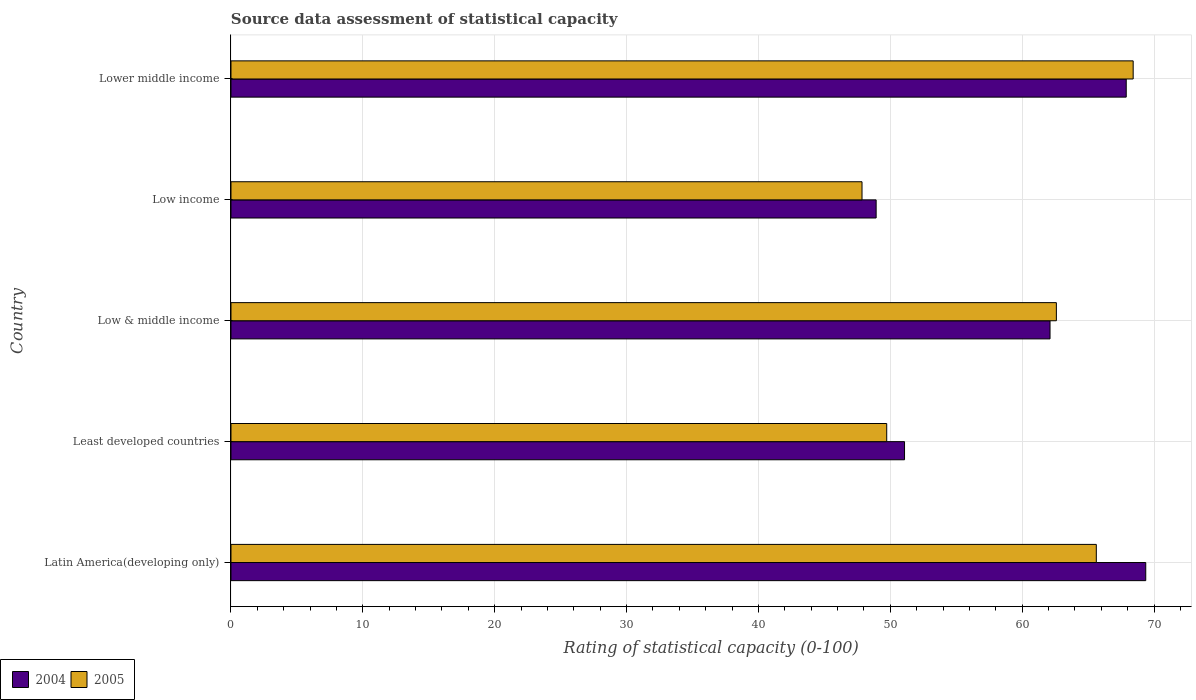How many groups of bars are there?
Offer a terse response. 5. Are the number of bars per tick equal to the number of legend labels?
Your response must be concise. Yes. Are the number of bars on each tick of the Y-axis equal?
Provide a short and direct response. Yes. What is the label of the 1st group of bars from the top?
Provide a short and direct response. Lower middle income. In how many cases, is the number of bars for a given country not equal to the number of legend labels?
Offer a terse response. 0. What is the rating of statistical capacity in 2005 in Latin America(developing only)?
Your response must be concise. 65.62. Across all countries, what is the maximum rating of statistical capacity in 2004?
Make the answer very short. 69.38. Across all countries, what is the minimum rating of statistical capacity in 2005?
Ensure brevity in your answer.  47.86. In which country was the rating of statistical capacity in 2004 maximum?
Ensure brevity in your answer.  Latin America(developing only). What is the total rating of statistical capacity in 2005 in the graph?
Provide a short and direct response. 294.23. What is the difference between the rating of statistical capacity in 2005 in Low income and that in Lower middle income?
Your answer should be very brief. -20.56. What is the difference between the rating of statistical capacity in 2005 in Lower middle income and the rating of statistical capacity in 2004 in Low & middle income?
Your response must be concise. 6.31. What is the average rating of statistical capacity in 2005 per country?
Your answer should be very brief. 58.85. What is the difference between the rating of statistical capacity in 2005 and rating of statistical capacity in 2004 in Lower middle income?
Your answer should be compact. 0.53. What is the ratio of the rating of statistical capacity in 2004 in Low income to that in Lower middle income?
Your answer should be very brief. 0.72. Is the rating of statistical capacity in 2004 in Latin America(developing only) less than that in Lower middle income?
Your answer should be very brief. No. Is the difference between the rating of statistical capacity in 2005 in Latin America(developing only) and Low income greater than the difference between the rating of statistical capacity in 2004 in Latin America(developing only) and Low income?
Keep it short and to the point. No. What is the difference between the highest and the second highest rating of statistical capacity in 2004?
Offer a very short reply. 1.48. What is the difference between the highest and the lowest rating of statistical capacity in 2004?
Give a very brief answer. 20.45. In how many countries, is the rating of statistical capacity in 2004 greater than the average rating of statistical capacity in 2004 taken over all countries?
Keep it short and to the point. 3. Is the sum of the rating of statistical capacity in 2005 in Latin America(developing only) and Low & middle income greater than the maximum rating of statistical capacity in 2004 across all countries?
Offer a terse response. Yes. What does the 2nd bar from the top in Latin America(developing only) represents?
Give a very brief answer. 2004. What does the 1st bar from the bottom in Least developed countries represents?
Your answer should be compact. 2004. What is the difference between two consecutive major ticks on the X-axis?
Offer a terse response. 10. Are the values on the major ticks of X-axis written in scientific E-notation?
Offer a very short reply. No. Does the graph contain grids?
Offer a terse response. Yes. Where does the legend appear in the graph?
Provide a succinct answer. Bottom left. How are the legend labels stacked?
Offer a terse response. Horizontal. What is the title of the graph?
Your answer should be very brief. Source data assessment of statistical capacity. Does "2005" appear as one of the legend labels in the graph?
Make the answer very short. Yes. What is the label or title of the X-axis?
Offer a very short reply. Rating of statistical capacity (0-100). What is the Rating of statistical capacity (0-100) in 2004 in Latin America(developing only)?
Provide a succinct answer. 69.38. What is the Rating of statistical capacity (0-100) in 2005 in Latin America(developing only)?
Ensure brevity in your answer.  65.62. What is the Rating of statistical capacity (0-100) of 2004 in Least developed countries?
Ensure brevity in your answer.  51.08. What is the Rating of statistical capacity (0-100) in 2005 in Least developed countries?
Ensure brevity in your answer.  49.73. What is the Rating of statistical capacity (0-100) of 2004 in Low & middle income?
Offer a terse response. 62.12. What is the Rating of statistical capacity (0-100) in 2005 in Low & middle income?
Your response must be concise. 62.6. What is the Rating of statistical capacity (0-100) in 2004 in Low income?
Give a very brief answer. 48.93. What is the Rating of statistical capacity (0-100) of 2005 in Low income?
Offer a terse response. 47.86. What is the Rating of statistical capacity (0-100) of 2004 in Lower middle income?
Offer a terse response. 67.89. What is the Rating of statistical capacity (0-100) in 2005 in Lower middle income?
Offer a terse response. 68.42. Across all countries, what is the maximum Rating of statistical capacity (0-100) of 2004?
Your answer should be compact. 69.38. Across all countries, what is the maximum Rating of statistical capacity (0-100) of 2005?
Keep it short and to the point. 68.42. Across all countries, what is the minimum Rating of statistical capacity (0-100) in 2004?
Your answer should be very brief. 48.93. Across all countries, what is the minimum Rating of statistical capacity (0-100) of 2005?
Provide a succinct answer. 47.86. What is the total Rating of statistical capacity (0-100) in 2004 in the graph?
Provide a short and direct response. 299.39. What is the total Rating of statistical capacity (0-100) in 2005 in the graph?
Provide a short and direct response. 294.23. What is the difference between the Rating of statistical capacity (0-100) of 2004 in Latin America(developing only) and that in Least developed countries?
Keep it short and to the point. 18.29. What is the difference between the Rating of statistical capacity (0-100) in 2005 in Latin America(developing only) and that in Least developed countries?
Keep it short and to the point. 15.9. What is the difference between the Rating of statistical capacity (0-100) in 2004 in Latin America(developing only) and that in Low & middle income?
Offer a terse response. 7.26. What is the difference between the Rating of statistical capacity (0-100) in 2005 in Latin America(developing only) and that in Low & middle income?
Offer a terse response. 3.03. What is the difference between the Rating of statistical capacity (0-100) of 2004 in Latin America(developing only) and that in Low income?
Your response must be concise. 20.45. What is the difference between the Rating of statistical capacity (0-100) of 2005 in Latin America(developing only) and that in Low income?
Offer a terse response. 17.77. What is the difference between the Rating of statistical capacity (0-100) in 2004 in Latin America(developing only) and that in Lower middle income?
Your answer should be compact. 1.48. What is the difference between the Rating of statistical capacity (0-100) in 2005 in Latin America(developing only) and that in Lower middle income?
Provide a short and direct response. -2.8. What is the difference between the Rating of statistical capacity (0-100) of 2004 in Least developed countries and that in Low & middle income?
Offer a very short reply. -11.03. What is the difference between the Rating of statistical capacity (0-100) in 2005 in Least developed countries and that in Low & middle income?
Ensure brevity in your answer.  -12.87. What is the difference between the Rating of statistical capacity (0-100) of 2004 in Least developed countries and that in Low income?
Your answer should be compact. 2.15. What is the difference between the Rating of statistical capacity (0-100) in 2005 in Least developed countries and that in Low income?
Your response must be concise. 1.87. What is the difference between the Rating of statistical capacity (0-100) in 2004 in Least developed countries and that in Lower middle income?
Your answer should be compact. -16.81. What is the difference between the Rating of statistical capacity (0-100) in 2005 in Least developed countries and that in Lower middle income?
Ensure brevity in your answer.  -18.69. What is the difference between the Rating of statistical capacity (0-100) in 2004 in Low & middle income and that in Low income?
Keep it short and to the point. 13.19. What is the difference between the Rating of statistical capacity (0-100) in 2005 in Low & middle income and that in Low income?
Provide a succinct answer. 14.74. What is the difference between the Rating of statistical capacity (0-100) of 2004 in Low & middle income and that in Lower middle income?
Give a very brief answer. -5.78. What is the difference between the Rating of statistical capacity (0-100) in 2005 in Low & middle income and that in Lower middle income?
Your answer should be very brief. -5.82. What is the difference between the Rating of statistical capacity (0-100) in 2004 in Low income and that in Lower middle income?
Your answer should be very brief. -18.97. What is the difference between the Rating of statistical capacity (0-100) of 2005 in Low income and that in Lower middle income?
Your answer should be very brief. -20.56. What is the difference between the Rating of statistical capacity (0-100) in 2004 in Latin America(developing only) and the Rating of statistical capacity (0-100) in 2005 in Least developed countries?
Your answer should be very brief. 19.65. What is the difference between the Rating of statistical capacity (0-100) of 2004 in Latin America(developing only) and the Rating of statistical capacity (0-100) of 2005 in Low & middle income?
Offer a terse response. 6.78. What is the difference between the Rating of statistical capacity (0-100) of 2004 in Latin America(developing only) and the Rating of statistical capacity (0-100) of 2005 in Low income?
Your answer should be compact. 21.52. What is the difference between the Rating of statistical capacity (0-100) in 2004 in Latin America(developing only) and the Rating of statistical capacity (0-100) in 2005 in Lower middle income?
Offer a very short reply. 0.95. What is the difference between the Rating of statistical capacity (0-100) of 2004 in Least developed countries and the Rating of statistical capacity (0-100) of 2005 in Low & middle income?
Provide a succinct answer. -11.52. What is the difference between the Rating of statistical capacity (0-100) in 2004 in Least developed countries and the Rating of statistical capacity (0-100) in 2005 in Low income?
Give a very brief answer. 3.22. What is the difference between the Rating of statistical capacity (0-100) in 2004 in Least developed countries and the Rating of statistical capacity (0-100) in 2005 in Lower middle income?
Keep it short and to the point. -17.34. What is the difference between the Rating of statistical capacity (0-100) in 2004 in Low & middle income and the Rating of statistical capacity (0-100) in 2005 in Low income?
Keep it short and to the point. 14.26. What is the difference between the Rating of statistical capacity (0-100) of 2004 in Low & middle income and the Rating of statistical capacity (0-100) of 2005 in Lower middle income?
Offer a very short reply. -6.31. What is the difference between the Rating of statistical capacity (0-100) of 2004 in Low income and the Rating of statistical capacity (0-100) of 2005 in Lower middle income?
Your response must be concise. -19.49. What is the average Rating of statistical capacity (0-100) in 2004 per country?
Give a very brief answer. 59.88. What is the average Rating of statistical capacity (0-100) of 2005 per country?
Your answer should be very brief. 58.85. What is the difference between the Rating of statistical capacity (0-100) in 2004 and Rating of statistical capacity (0-100) in 2005 in Latin America(developing only)?
Offer a very short reply. 3.75. What is the difference between the Rating of statistical capacity (0-100) of 2004 and Rating of statistical capacity (0-100) of 2005 in Least developed countries?
Give a very brief answer. 1.35. What is the difference between the Rating of statistical capacity (0-100) in 2004 and Rating of statistical capacity (0-100) in 2005 in Low & middle income?
Keep it short and to the point. -0.48. What is the difference between the Rating of statistical capacity (0-100) of 2004 and Rating of statistical capacity (0-100) of 2005 in Low income?
Ensure brevity in your answer.  1.07. What is the difference between the Rating of statistical capacity (0-100) of 2004 and Rating of statistical capacity (0-100) of 2005 in Lower middle income?
Keep it short and to the point. -0.53. What is the ratio of the Rating of statistical capacity (0-100) of 2004 in Latin America(developing only) to that in Least developed countries?
Offer a very short reply. 1.36. What is the ratio of the Rating of statistical capacity (0-100) of 2005 in Latin America(developing only) to that in Least developed countries?
Ensure brevity in your answer.  1.32. What is the ratio of the Rating of statistical capacity (0-100) in 2004 in Latin America(developing only) to that in Low & middle income?
Your answer should be very brief. 1.12. What is the ratio of the Rating of statistical capacity (0-100) of 2005 in Latin America(developing only) to that in Low & middle income?
Give a very brief answer. 1.05. What is the ratio of the Rating of statistical capacity (0-100) in 2004 in Latin America(developing only) to that in Low income?
Your response must be concise. 1.42. What is the ratio of the Rating of statistical capacity (0-100) in 2005 in Latin America(developing only) to that in Low income?
Your answer should be compact. 1.37. What is the ratio of the Rating of statistical capacity (0-100) of 2004 in Latin America(developing only) to that in Lower middle income?
Give a very brief answer. 1.02. What is the ratio of the Rating of statistical capacity (0-100) of 2005 in Latin America(developing only) to that in Lower middle income?
Your answer should be compact. 0.96. What is the ratio of the Rating of statistical capacity (0-100) in 2004 in Least developed countries to that in Low & middle income?
Your answer should be very brief. 0.82. What is the ratio of the Rating of statistical capacity (0-100) of 2005 in Least developed countries to that in Low & middle income?
Your answer should be very brief. 0.79. What is the ratio of the Rating of statistical capacity (0-100) of 2004 in Least developed countries to that in Low income?
Your answer should be very brief. 1.04. What is the ratio of the Rating of statistical capacity (0-100) in 2005 in Least developed countries to that in Low income?
Offer a terse response. 1.04. What is the ratio of the Rating of statistical capacity (0-100) of 2004 in Least developed countries to that in Lower middle income?
Give a very brief answer. 0.75. What is the ratio of the Rating of statistical capacity (0-100) of 2005 in Least developed countries to that in Lower middle income?
Offer a terse response. 0.73. What is the ratio of the Rating of statistical capacity (0-100) in 2004 in Low & middle income to that in Low income?
Provide a short and direct response. 1.27. What is the ratio of the Rating of statistical capacity (0-100) of 2005 in Low & middle income to that in Low income?
Your answer should be compact. 1.31. What is the ratio of the Rating of statistical capacity (0-100) in 2004 in Low & middle income to that in Lower middle income?
Offer a terse response. 0.91. What is the ratio of the Rating of statistical capacity (0-100) of 2005 in Low & middle income to that in Lower middle income?
Provide a short and direct response. 0.91. What is the ratio of the Rating of statistical capacity (0-100) of 2004 in Low income to that in Lower middle income?
Your answer should be compact. 0.72. What is the ratio of the Rating of statistical capacity (0-100) in 2005 in Low income to that in Lower middle income?
Ensure brevity in your answer.  0.7. What is the difference between the highest and the second highest Rating of statistical capacity (0-100) of 2004?
Your response must be concise. 1.48. What is the difference between the highest and the second highest Rating of statistical capacity (0-100) of 2005?
Provide a short and direct response. 2.8. What is the difference between the highest and the lowest Rating of statistical capacity (0-100) in 2004?
Make the answer very short. 20.45. What is the difference between the highest and the lowest Rating of statistical capacity (0-100) in 2005?
Ensure brevity in your answer.  20.56. 